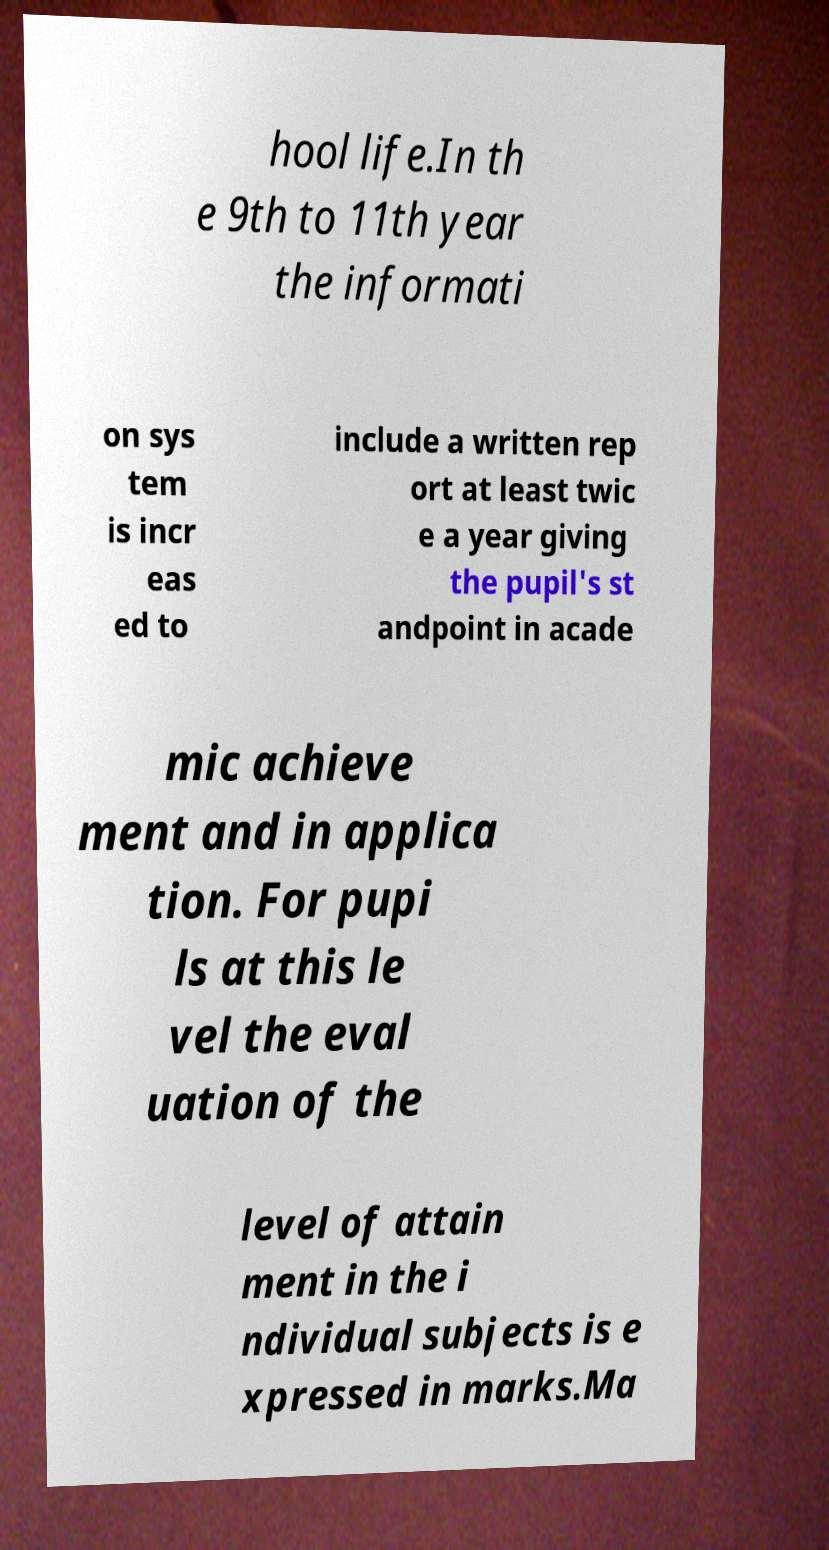There's text embedded in this image that I need extracted. Can you transcribe it verbatim? hool life.In th e 9th to 11th year the informati on sys tem is incr eas ed to include a written rep ort at least twic e a year giving the pupil's st andpoint in acade mic achieve ment and in applica tion. For pupi ls at this le vel the eval uation of the level of attain ment in the i ndividual subjects is e xpressed in marks.Ma 